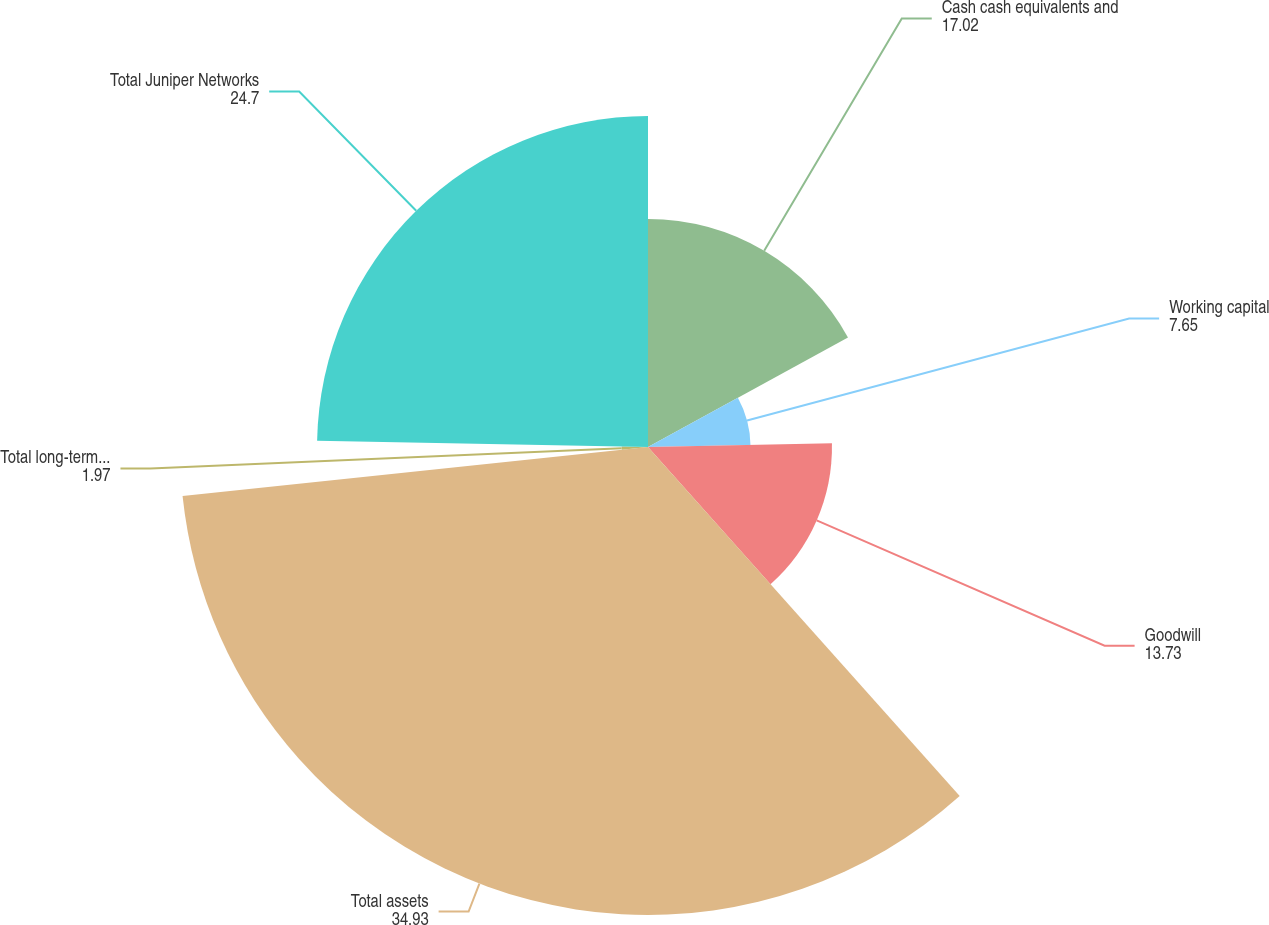Convert chart. <chart><loc_0><loc_0><loc_500><loc_500><pie_chart><fcel>Cash cash equivalents and<fcel>Working capital<fcel>Goodwill<fcel>Total assets<fcel>Total long-term liabilities<fcel>Total Juniper Networks<nl><fcel>17.02%<fcel>7.65%<fcel>13.73%<fcel>34.93%<fcel>1.97%<fcel>24.7%<nl></chart> 